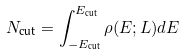Convert formula to latex. <formula><loc_0><loc_0><loc_500><loc_500>N _ { \text {cut} } = \int _ { - E _ { \text {cut} } } ^ { E _ { \text {cut} } } \rho ( E ; L ) d E</formula> 